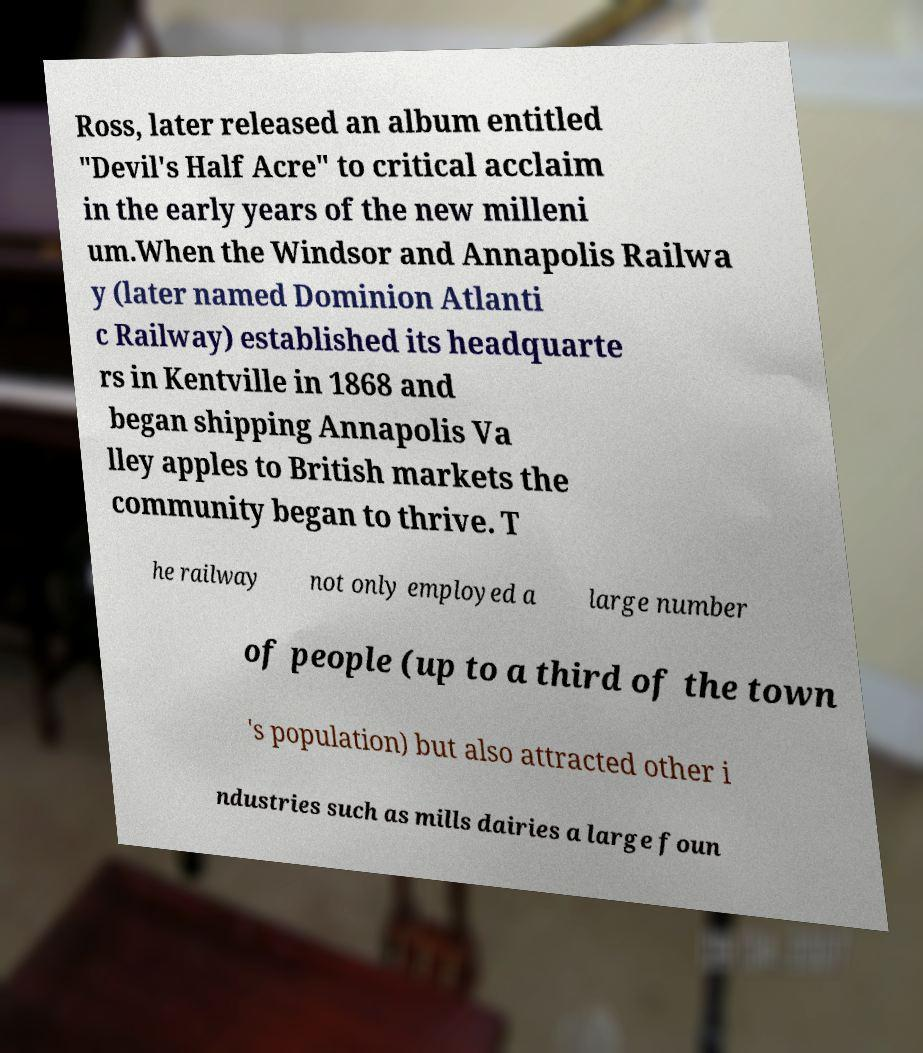What messages or text are displayed in this image? I need them in a readable, typed format. Ross, later released an album entitled "Devil's Half Acre" to critical acclaim in the early years of the new milleni um.When the Windsor and Annapolis Railwa y (later named Dominion Atlanti c Railway) established its headquarte rs in Kentville in 1868 and began shipping Annapolis Va lley apples to British markets the community began to thrive. T he railway not only employed a large number of people (up to a third of the town 's population) but also attracted other i ndustries such as mills dairies a large foun 